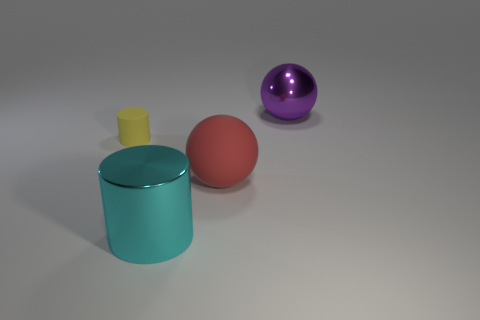Is there any other thing that has the same size as the yellow thing?
Your answer should be very brief. No. What number of big yellow things are the same shape as the large purple metal object?
Your response must be concise. 0. How many objects are big metal objects in front of the big shiny ball or matte objects that are in front of the tiny yellow cylinder?
Make the answer very short. 2. How many gray things are metal objects or cylinders?
Provide a succinct answer. 0. There is a large object that is to the right of the big cyan metallic thing and in front of the tiny cylinder; what material is it?
Offer a terse response. Rubber. Is the cyan thing made of the same material as the yellow object?
Your answer should be very brief. No. What number of red things have the same size as the yellow matte cylinder?
Your answer should be compact. 0. Is the number of shiny cylinders behind the tiny thing the same as the number of big cyan metallic objects?
Provide a short and direct response. No. What number of objects are both on the right side of the cyan shiny thing and in front of the purple sphere?
Provide a short and direct response. 1. There is a thing that is in front of the large rubber ball; is it the same shape as the purple metallic object?
Offer a terse response. No. 